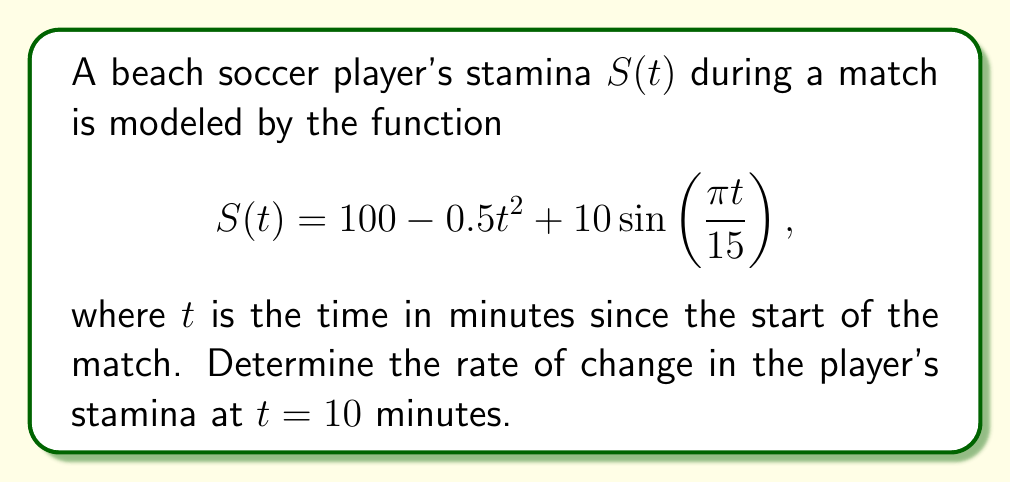What is the answer to this math problem? To find the rate of change in the player's stamina at $t = 10$ minutes, we need to calculate the derivative of $S(t)$ and evaluate it at $t = 10$.

1) First, let's find the derivative of $S(t)$:
   $$\frac{d}{dt}S(t) = \frac{d}{dt}(100 - 0.5t^2 + 10\sin(\frac{\pi t}{15}))$$
   
   $$S'(t) = -t + 10\cdot\frac{\pi}{15}\cos(\frac{\pi t}{15})$$

2) Now, we evaluate $S'(t)$ at $t = 10$:
   $$S'(10) = -10 + 10\cdot\frac{\pi}{15}\cos(\frac{\pi \cdot 10}{15})$$
   
   $$= -10 + \frac{2\pi}{3}\cos(\frac{2\pi}{3})$$

3) Simplify:
   $$= -10 + \frac{2\pi}{3}\cdot(-\frac{1}{2})$$
   
   $$= -10 - \frac{\pi}{3}$$

4) Calculate the final value:
   $$\approx -11.05$$

The negative value indicates that the player's stamina is decreasing at this point in the match.
Answer: $-11.05$ stamina units per minute 